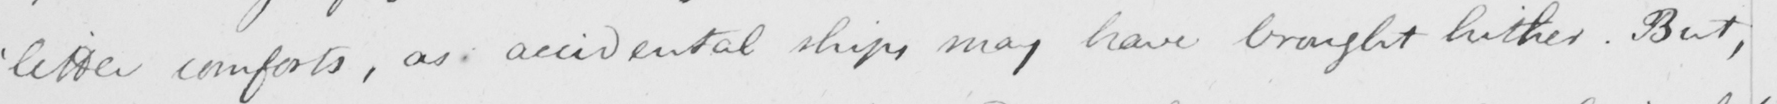What is written in this line of handwriting? ' little comforts , as accidental ships may have brought hither . But , 